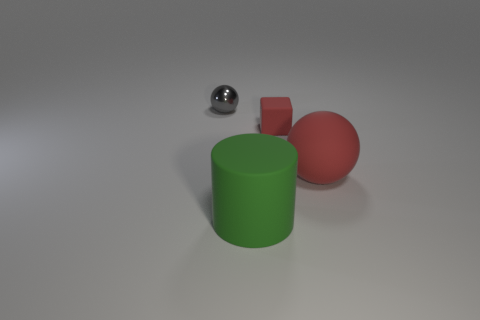Add 3 small metallic spheres. How many objects exist? 7 Subtract all cylinders. How many objects are left? 3 Subtract 0 brown spheres. How many objects are left? 4 Subtract all red spheres. Subtract all small rubber objects. How many objects are left? 2 Add 3 green cylinders. How many green cylinders are left? 4 Add 1 big red things. How many big red things exist? 2 